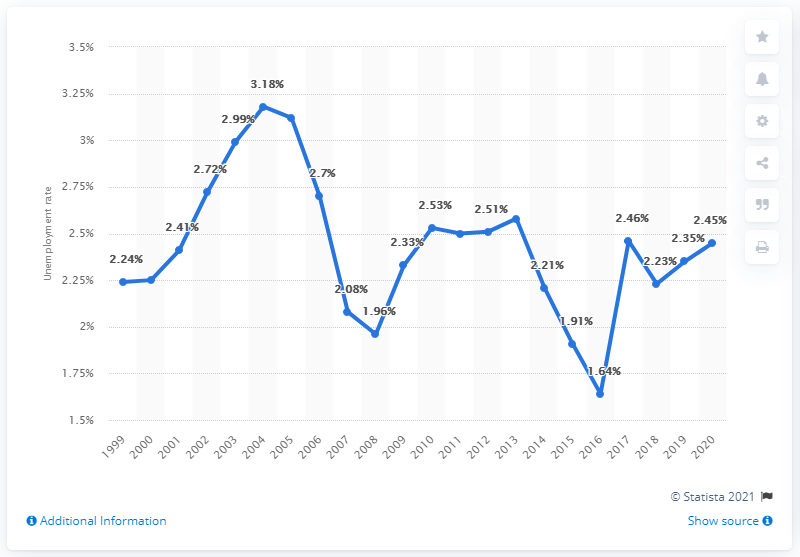List a handful of essential elements in this visual. The unemployment rate in the United Arab Emirates in 2020 was 2.45%. 